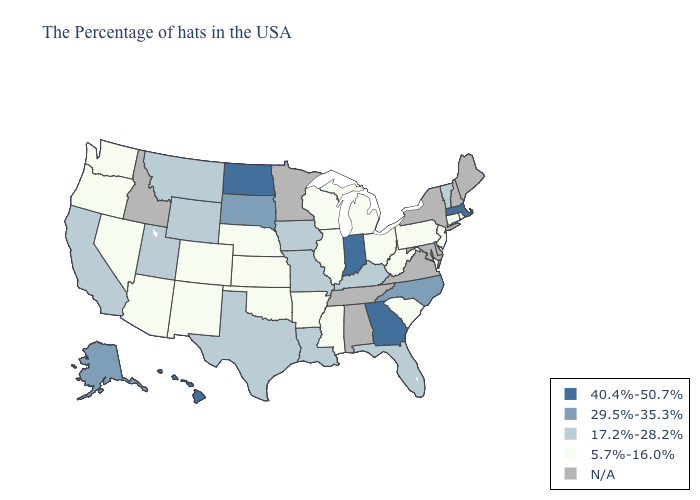What is the lowest value in states that border Tennessee?
Answer briefly. 5.7%-16.0%. Name the states that have a value in the range 5.7%-16.0%?
Concise answer only. Rhode Island, Connecticut, New Jersey, Pennsylvania, South Carolina, West Virginia, Ohio, Michigan, Wisconsin, Illinois, Mississippi, Arkansas, Kansas, Nebraska, Oklahoma, Colorado, New Mexico, Arizona, Nevada, Washington, Oregon. Does Ohio have the highest value in the USA?
Short answer required. No. Does Arizona have the lowest value in the USA?
Concise answer only. Yes. What is the value of Connecticut?
Quick response, please. 5.7%-16.0%. What is the value of Colorado?
Quick response, please. 5.7%-16.0%. What is the lowest value in states that border Minnesota?
Short answer required. 5.7%-16.0%. What is the value of Oregon?
Give a very brief answer. 5.7%-16.0%. Which states hav the highest value in the West?
Keep it brief. Hawaii. Does Nebraska have the lowest value in the USA?
Short answer required. Yes. What is the value of Montana?
Write a very short answer. 17.2%-28.2%. Name the states that have a value in the range 17.2%-28.2%?
Quick response, please. Vermont, Florida, Kentucky, Louisiana, Missouri, Iowa, Texas, Wyoming, Utah, Montana, California. Does Oklahoma have the highest value in the USA?
Be succinct. No. 